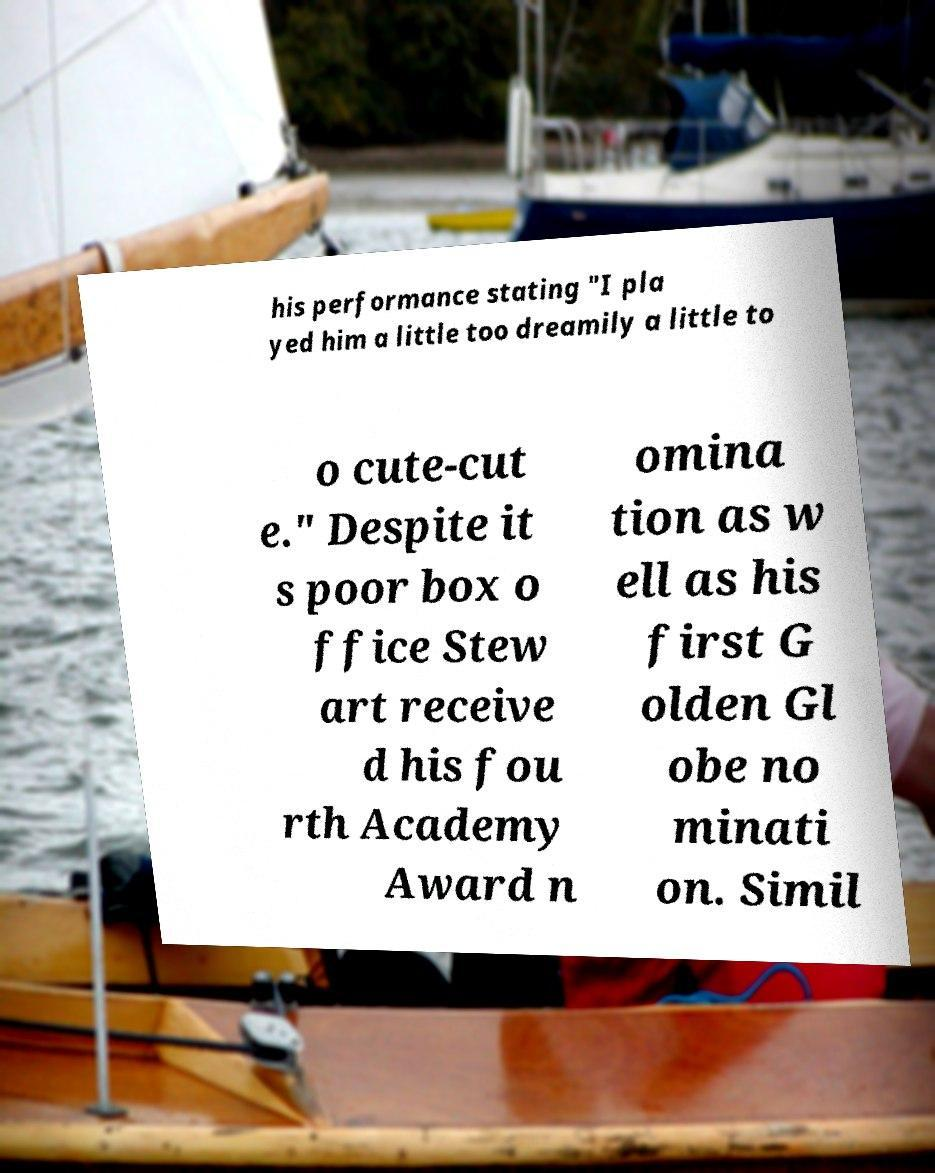Can you accurately transcribe the text from the provided image for me? his performance stating "I pla yed him a little too dreamily a little to o cute-cut e." Despite it s poor box o ffice Stew art receive d his fou rth Academy Award n omina tion as w ell as his first G olden Gl obe no minati on. Simil 